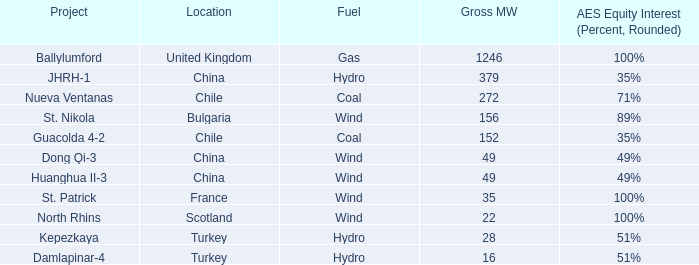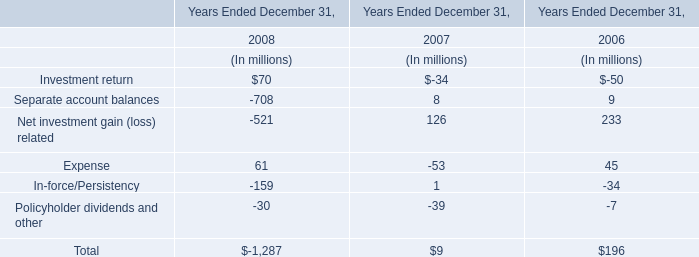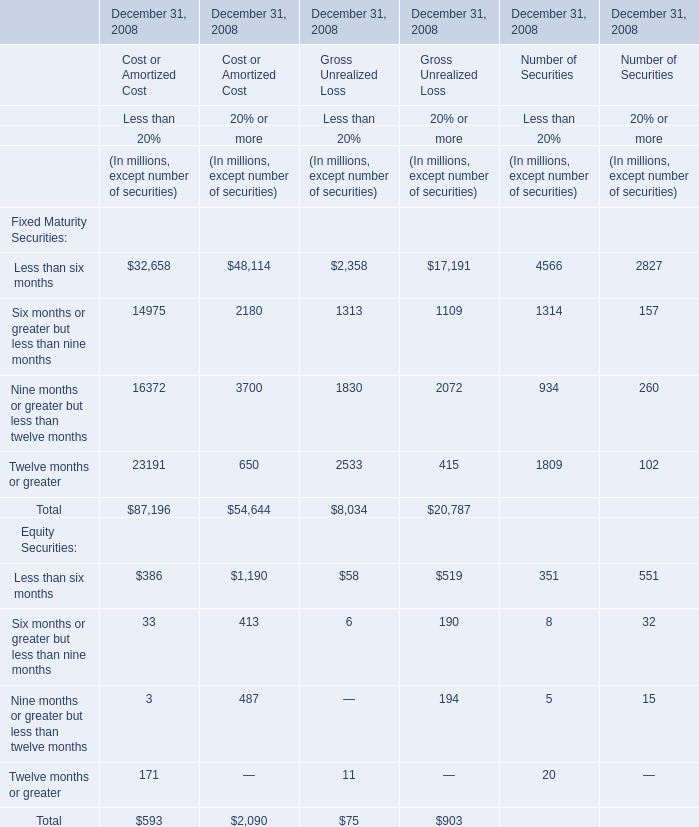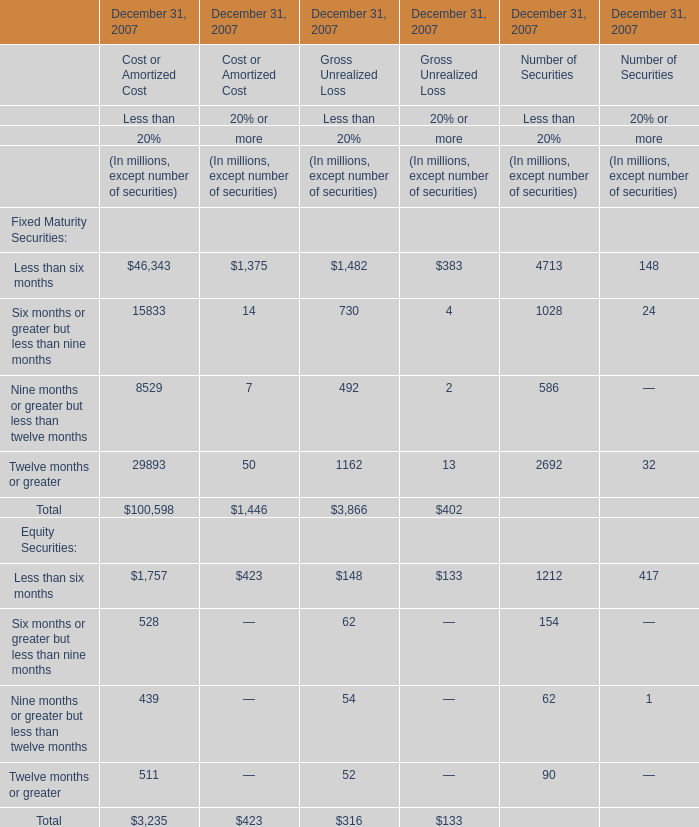Which section is Less than six months the highest? 
Answer: Cost or Amortized Cost 20% or more. 